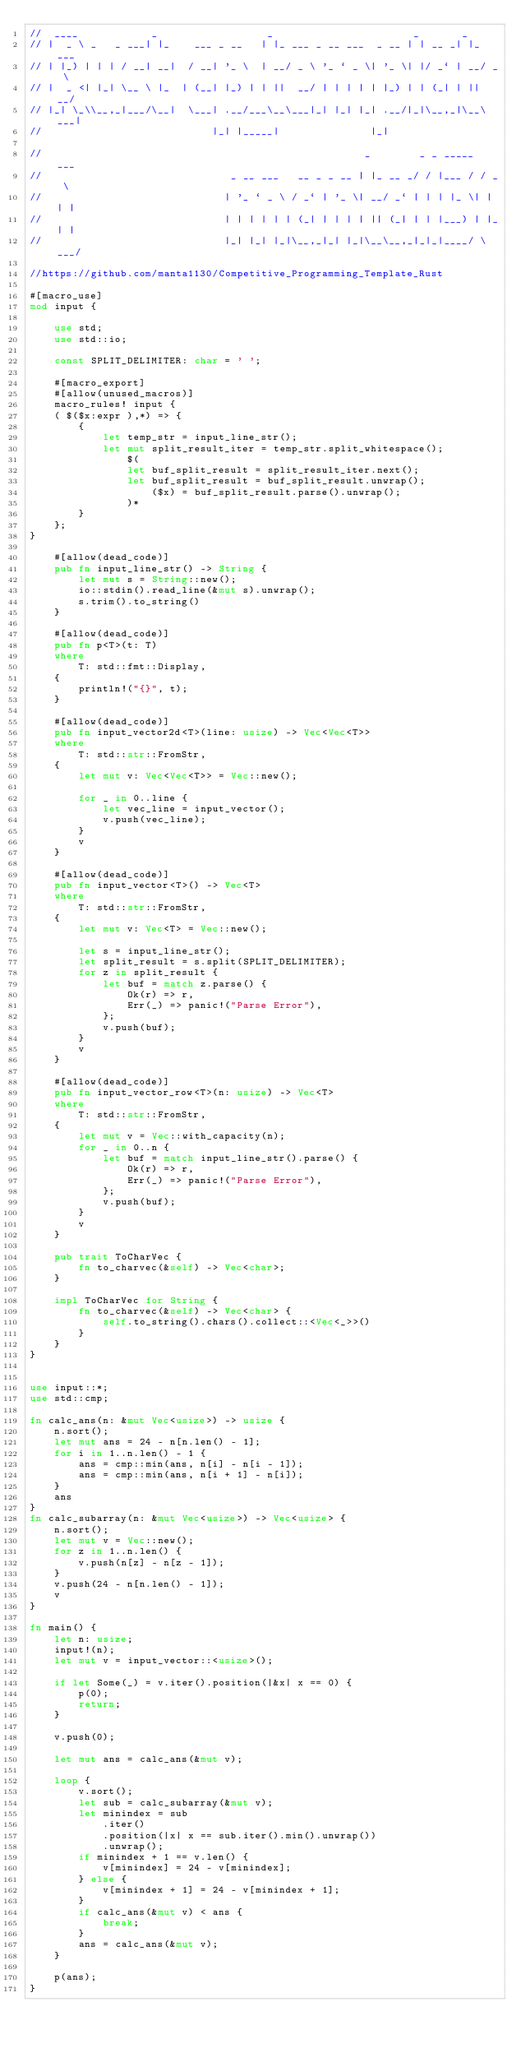<code> <loc_0><loc_0><loc_500><loc_500><_Rust_>//  ____            _                  _                       _       _
// |  _ \ _   _ ___| |_    ___ _ __   | |_ ___ _ __ ___  _ __ | | __ _| |_ ___
// | |_) | | | / __| __|  / __| '_ \  | __/ _ \ '_ ` _ \| '_ \| |/ _` | __/ _ \
// |  _ <| |_| \__ \ |_  | (__| |_) | | ||  __/ | | | | | |_) | | (_| | ||  __/
// |_| \_\\__,_|___/\__|  \___| .__/___\__\___|_| |_| |_| .__/|_|\__,_|\__\___|
//                            |_| |_____|               |_|

//                                                     _        _ _ _____  ___
//                               _ __ ___   __ _ _ __ | |_ __ _/ / |___ / / _ \
//                              | '_ ` _ \ / _` | '_ \| __/ _` | | | |_ \| | | |
//                              | | | | | | (_| | | | | || (_| | | |___) | |_| |
//                              |_| |_| |_|\__,_|_| |_|\__\__,_|_|_|____/ \___/

//https://github.com/manta1130/Competitive_Programming_Template_Rust

#[macro_use]
mod input {

    use std;
    use std::io;

    const SPLIT_DELIMITER: char = ' ';

    #[macro_export]
    #[allow(unused_macros)]
    macro_rules! input {
    ( $($x:expr ),*) => {
        {
            let temp_str = input_line_str();
            let mut split_result_iter = temp_str.split_whitespace();
                $(
                let buf_split_result = split_result_iter.next();
                let buf_split_result = buf_split_result.unwrap();
                    ($x) = buf_split_result.parse().unwrap();
                )*
        }
    };
}

    #[allow(dead_code)]
    pub fn input_line_str() -> String {
        let mut s = String::new();
        io::stdin().read_line(&mut s).unwrap();
        s.trim().to_string()
    }

    #[allow(dead_code)]
    pub fn p<T>(t: T)
    where
        T: std::fmt::Display,
    {
        println!("{}", t);
    }

    #[allow(dead_code)]
    pub fn input_vector2d<T>(line: usize) -> Vec<Vec<T>>
    where
        T: std::str::FromStr,
    {
        let mut v: Vec<Vec<T>> = Vec::new();

        for _ in 0..line {
            let vec_line = input_vector();
            v.push(vec_line);
        }
        v
    }

    #[allow(dead_code)]
    pub fn input_vector<T>() -> Vec<T>
    where
        T: std::str::FromStr,
    {
        let mut v: Vec<T> = Vec::new();

        let s = input_line_str();
        let split_result = s.split(SPLIT_DELIMITER);
        for z in split_result {
            let buf = match z.parse() {
                Ok(r) => r,
                Err(_) => panic!("Parse Error"),
            };
            v.push(buf);
        }
        v
    }

    #[allow(dead_code)]
    pub fn input_vector_row<T>(n: usize) -> Vec<T>
    where
        T: std::str::FromStr,
    {
        let mut v = Vec::with_capacity(n);
        for _ in 0..n {
            let buf = match input_line_str().parse() {
                Ok(r) => r,
                Err(_) => panic!("Parse Error"),
            };
            v.push(buf);
        }
        v
    }

    pub trait ToCharVec {
        fn to_charvec(&self) -> Vec<char>;
    }

    impl ToCharVec for String {
        fn to_charvec(&self) -> Vec<char> {
            self.to_string().chars().collect::<Vec<_>>()
        }
    }
}


use input::*;
use std::cmp;

fn calc_ans(n: &mut Vec<usize>) -> usize {
    n.sort();
    let mut ans = 24 - n[n.len() - 1];
    for i in 1..n.len() - 1 {
        ans = cmp::min(ans, n[i] - n[i - 1]);
        ans = cmp::min(ans, n[i + 1] - n[i]);
    }
    ans
}
fn calc_subarray(n: &mut Vec<usize>) -> Vec<usize> {
    n.sort();
    let mut v = Vec::new();
    for z in 1..n.len() {
        v.push(n[z] - n[z - 1]);
    }
    v.push(24 - n[n.len() - 1]);
    v
}

fn main() {
    let n: usize;
    input!(n);
    let mut v = input_vector::<usize>();

    if let Some(_) = v.iter().position(|&x| x == 0) {
        p(0);
        return;
    }

    v.push(0);

    let mut ans = calc_ans(&mut v);

    loop {
        v.sort();
        let sub = calc_subarray(&mut v);
        let minindex = sub
            .iter()
            .position(|x| x == sub.iter().min().unwrap())
            .unwrap();
        if minindex + 1 == v.len() {
            v[minindex] = 24 - v[minindex];
        } else {
            v[minindex + 1] = 24 - v[minindex + 1];
        }
        if calc_ans(&mut v) < ans {
            break;
        }
        ans = calc_ans(&mut v);
    }

    p(ans);
}
</code> 